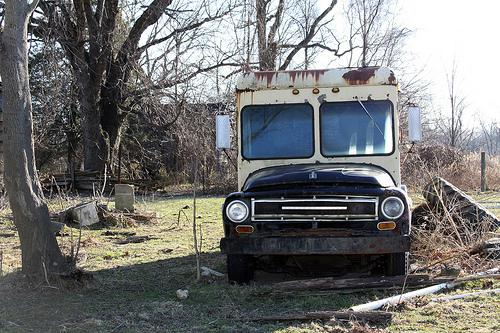What are the main features of the truck? The truck is old and rusty, has a rusted top, two front windows, white and yellow headlights, side view mirrors, windshield wipers, and a car brand emblem on the front. Explain the condition of the sky and landscape around the truck. The sky has sunlight and the landscape around the truck has green grass, bare trees, and discarded items. What objects can be found on the ground near the truck? Grass, truck's shadow, logs, pile of sticks, a gray metal pole, and a long white pole can be found on the ground near the truck. Describe the sentiment that can be sensed from the image. The image gives off a nostalgic and abandoned sentiment with an old, rusted truck surrounded by a desolate yard with bare trees and discarded articles. Which parts of the truck are rusted? The top, roof, and some metal on the truck are rusted. Analyze the condition of the truck and its background. The truck is old and rusted with some damaged parts, and it's parked in a yard with bare trees, green grass, and miscellaneous discarded items. Describe the environment surrounding the truck. There are bare, tall trees, green grass, a long white pole, and discarded articles around the truck. There's also a thick light brown tree, a fence post in the yard, and sunlight in the sky. What type of tree is located to the left of the truck? It is a gray tree trunk with tall dark brown branches. Do you see the graffiti painted on the side of the rusty truck? It appears to be a tag of some sort. No, it's not mentioned in the image. Find evidence of the truck headlights being round. The headlight is described as round in the caption. Select the most fitting description of the windshield wipers: b) They are not on the truck. Discuss the state of trees surrounding the truck. The trees are tall and bare near the vehicle. Is there any activity happening in the sky part of the image? Sunlight is visible in the sky. Identify any shadows cast by the truck. The truck's shadow is visible on the ground. Describe the tree trunks' colors and their location in the image. There are gray and light brown tree trunks near the truck. Notice the red stop sign on the right side of the truck. It seems to be worn and fading in color. There is no information about a red stop sign in the given captions. The instruction is a declarative sentence that suggests the presence of an object which is not actually part of the image. Mention the color and location of the truck mirrors. White, side view mirror on the side, and one on the front. Give a brief description of the side view mirrors on the truck. White, one on the side and one on the front. The orange traffic cone on the ground near the gray metal pole seems to be a bit cracked. There is no reference to an orange traffic cone within the given captions. The statement is a declarative sentence that falsely asserts the existence of an object in the image. Can you spot the pink bicycle leaning against the tree? It has a basket on the front.  There is no mention of a pink bicycle or a basket in any of the captions. The instruction is misleading because it asks the reader to look for an object that is not present in the image. List any additional objects found in the yard. Pile of sticks, fence post, white pole, and discarded articles. Are there any windows on the truck? If yes, where are they located? Yes, there are two front truck windows. Explain the condition of the truck and its age. The truck is old, rusted, and has two different captions describing it. Can you locate the small blue bird perched on one of the bare tree branches above the truck? It is looking for something. There is no mention of a blue bird or any living creatures in the given captions. This instruction, framed as an interrogative sentence, leads the reader to search for something that doesn't exist in the image. The broken street lamp beside the fence post is barely noticeable, as it is mostly concealed by the branches of the tall dark brown tree. The given captions do not make any mention of a broken street lamp or any lamps at all. This statement is a declarative sentence that introduces an object that is not present in the image, thereby misleading the reader. Elaborate on the truck's emblems and their placements. Car brand emblem is placed on the front of the truck. What color are the headlights on the truck? White and yellow What's the emotional expression of any person present in the image? There is no person present in the image. Describe the condition of the truck's roof. It is rusty and badly rusted. Is the truck parked, moving, or in any kind of action? The truck is parked. Describe the general state of the yard around the truck. The yard has discarded articles, green grass, a fence post, and a white long pole. What is the color of the grass in the image? The grass is green. 